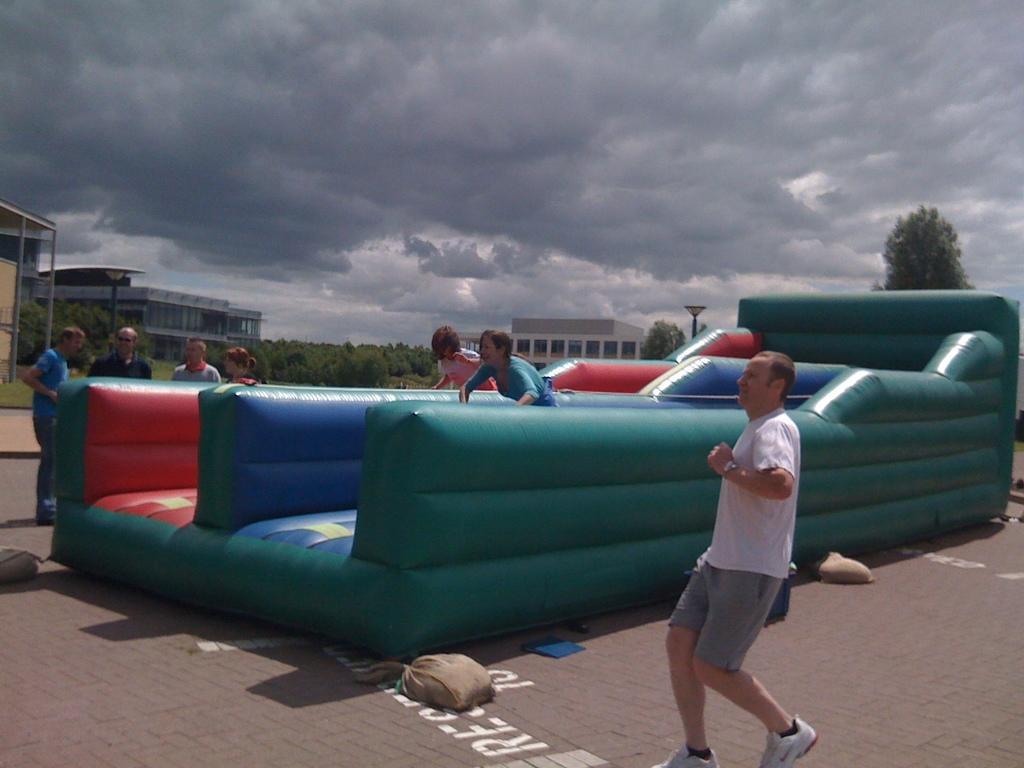Can you describe this image briefly? In the center of the image there is a inflatable. There are people on it. In the foreground of the image there is a person running. In the background of the image there are buildings, trees, sky. At the bottom of the image there is floor. 